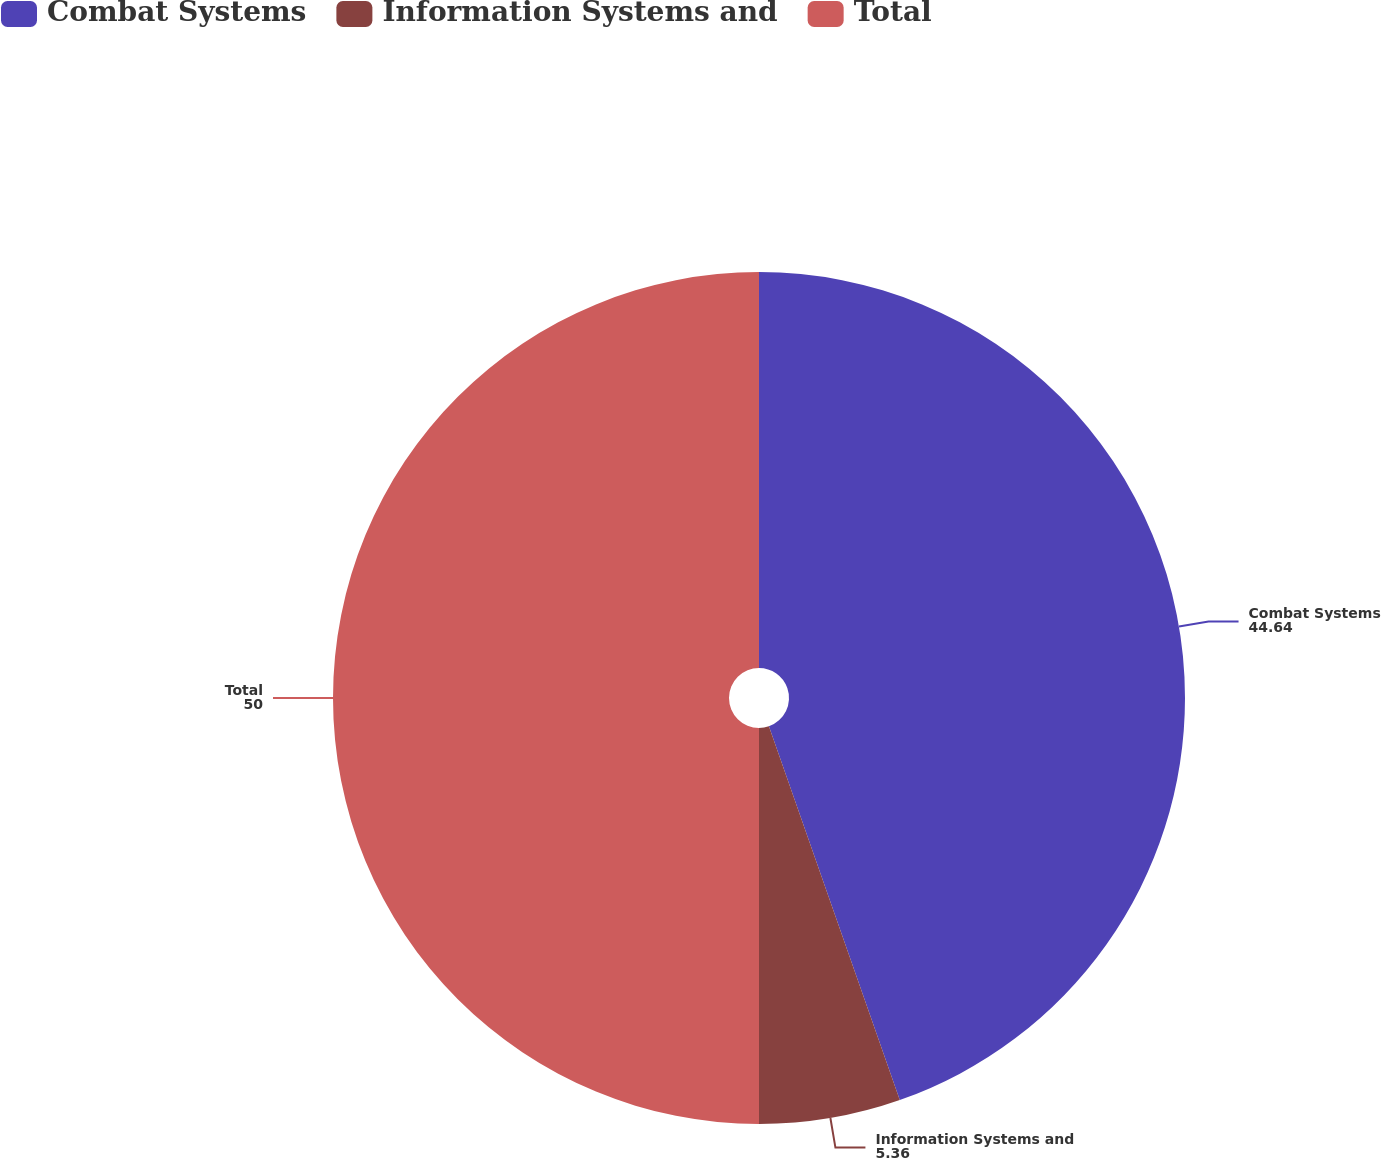Convert chart to OTSL. <chart><loc_0><loc_0><loc_500><loc_500><pie_chart><fcel>Combat Systems<fcel>Information Systems and<fcel>Total<nl><fcel>44.64%<fcel>5.36%<fcel>50.0%<nl></chart> 